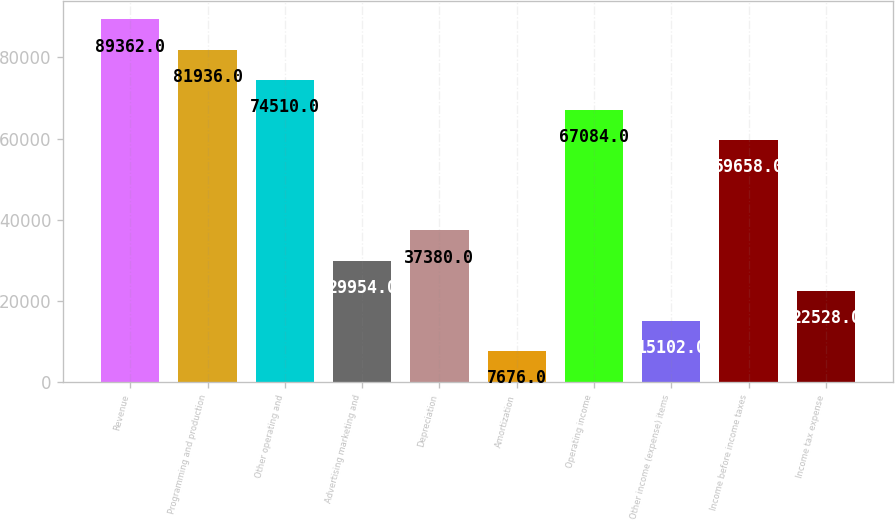Convert chart to OTSL. <chart><loc_0><loc_0><loc_500><loc_500><bar_chart><fcel>Revenue<fcel>Programming and production<fcel>Other operating and<fcel>Advertising marketing and<fcel>Depreciation<fcel>Amortization<fcel>Operating income<fcel>Other income (expense) items<fcel>Income before income taxes<fcel>Income tax expense<nl><fcel>89362<fcel>81936<fcel>74510<fcel>29954<fcel>37380<fcel>7676<fcel>67084<fcel>15102<fcel>59658<fcel>22528<nl></chart> 